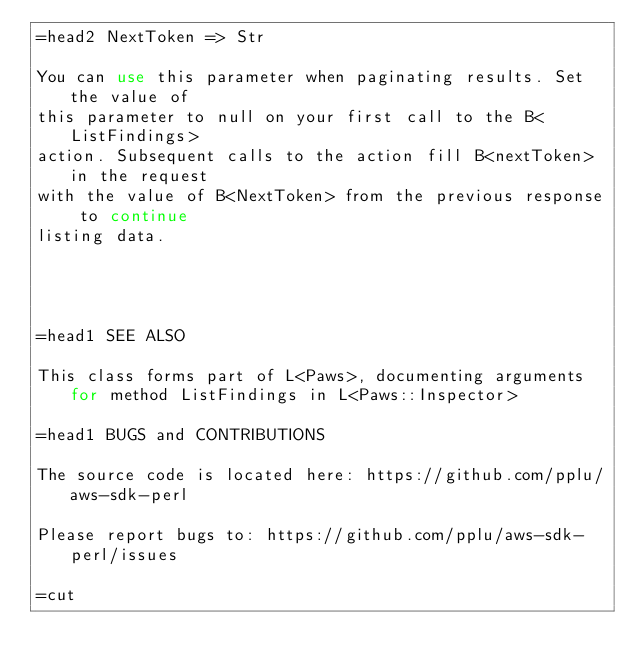Convert code to text. <code><loc_0><loc_0><loc_500><loc_500><_Perl_>=head2 NextToken => Str

You can use this parameter when paginating results. Set the value of
this parameter to null on your first call to the B<ListFindings>
action. Subsequent calls to the action fill B<nextToken> in the request
with the value of B<NextToken> from the previous response to continue
listing data.




=head1 SEE ALSO

This class forms part of L<Paws>, documenting arguments for method ListFindings in L<Paws::Inspector>

=head1 BUGS and CONTRIBUTIONS

The source code is located here: https://github.com/pplu/aws-sdk-perl

Please report bugs to: https://github.com/pplu/aws-sdk-perl/issues

=cut

</code> 